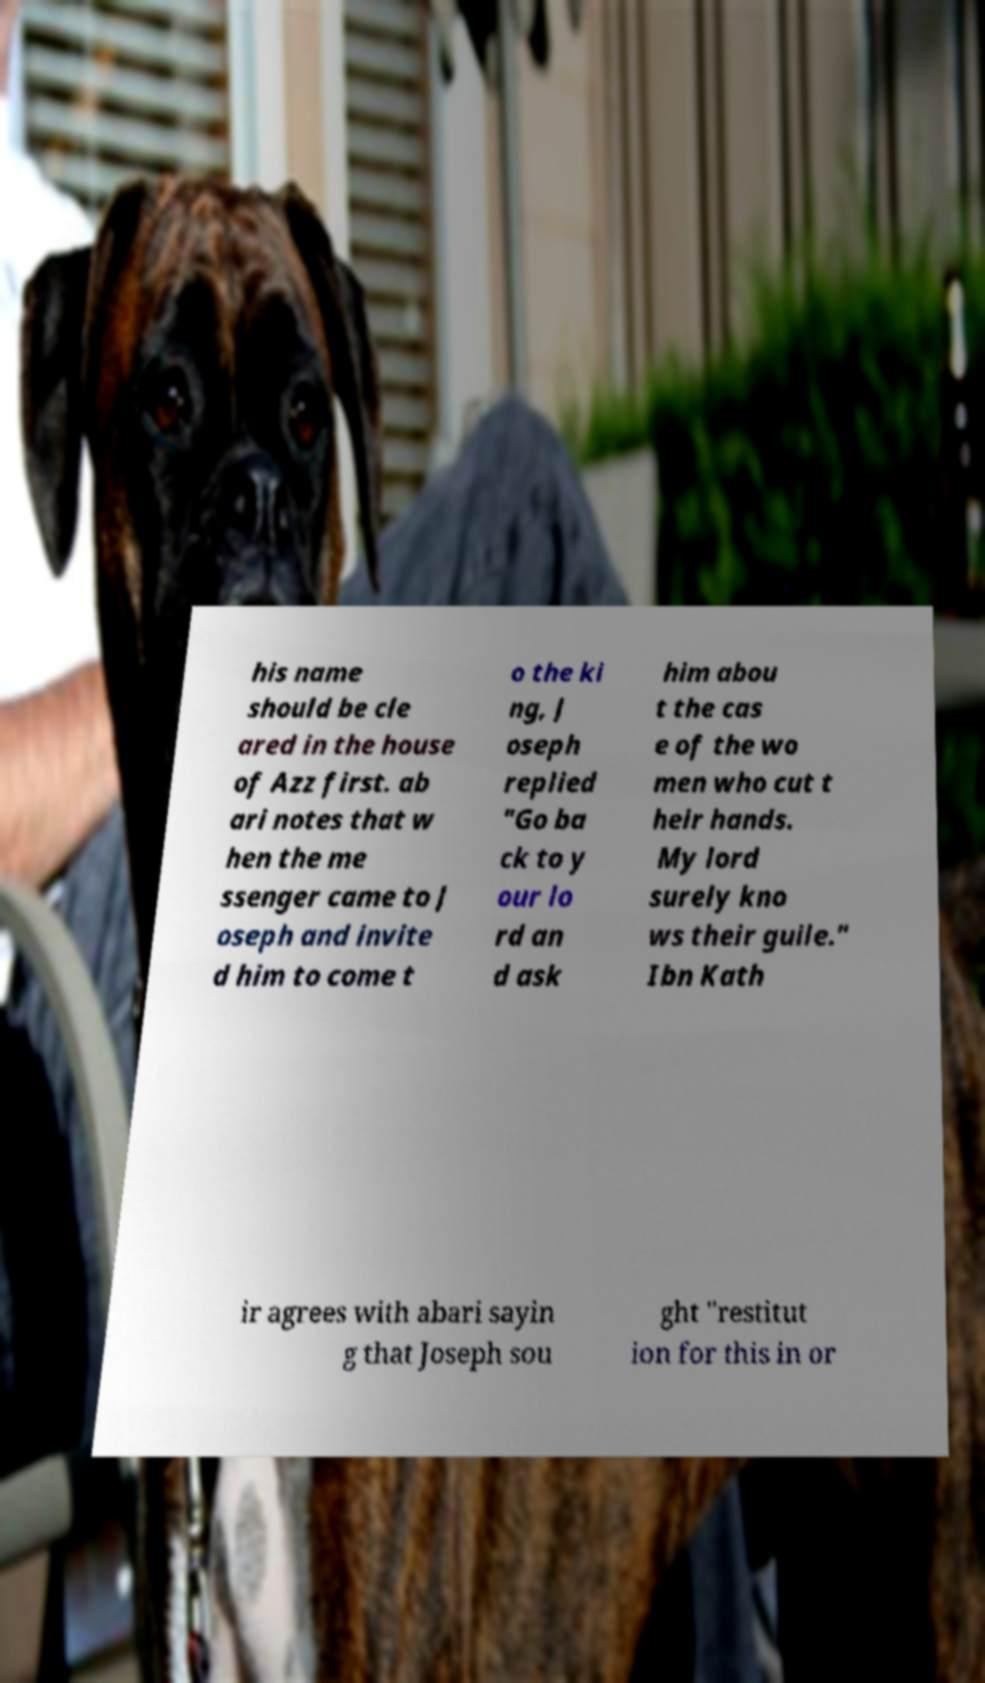Can you accurately transcribe the text from the provided image for me? his name should be cle ared in the house of Azz first. ab ari notes that w hen the me ssenger came to J oseph and invite d him to come t o the ki ng, J oseph replied "Go ba ck to y our lo rd an d ask him abou t the cas e of the wo men who cut t heir hands. My lord surely kno ws their guile." Ibn Kath ir agrees with abari sayin g that Joseph sou ght "restitut ion for this in or 